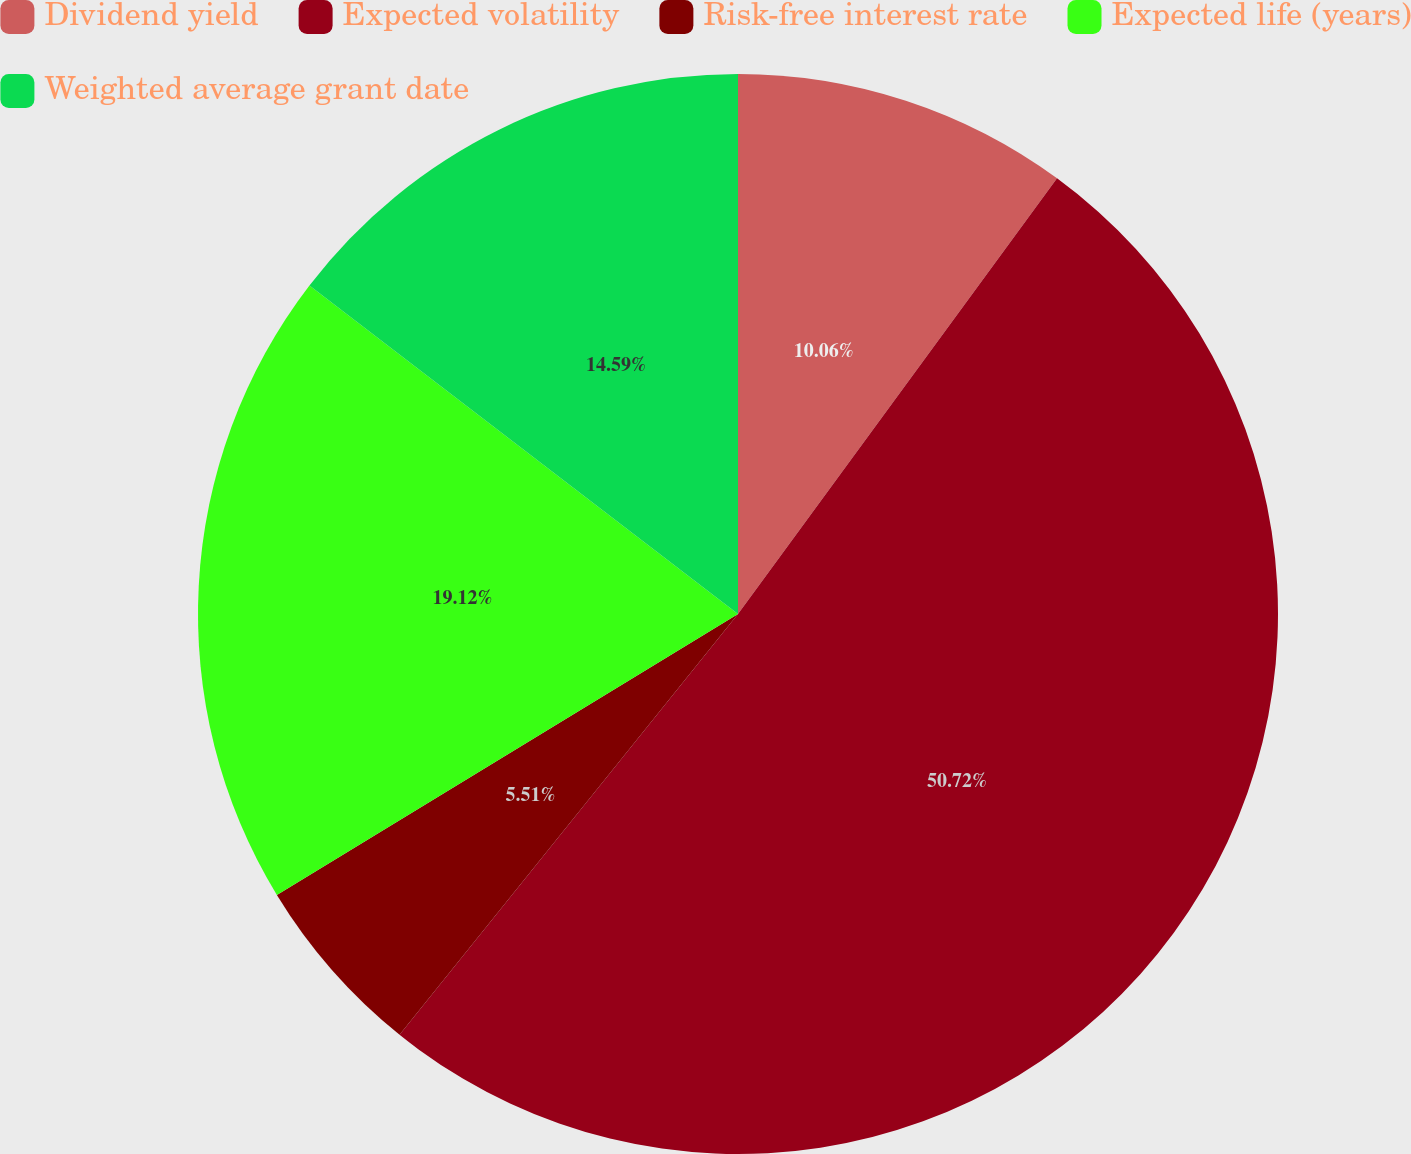Convert chart. <chart><loc_0><loc_0><loc_500><loc_500><pie_chart><fcel>Dividend yield<fcel>Expected volatility<fcel>Risk-free interest rate<fcel>Expected life (years)<fcel>Weighted average grant date<nl><fcel>10.06%<fcel>50.72%<fcel>5.51%<fcel>19.12%<fcel>14.59%<nl></chart> 